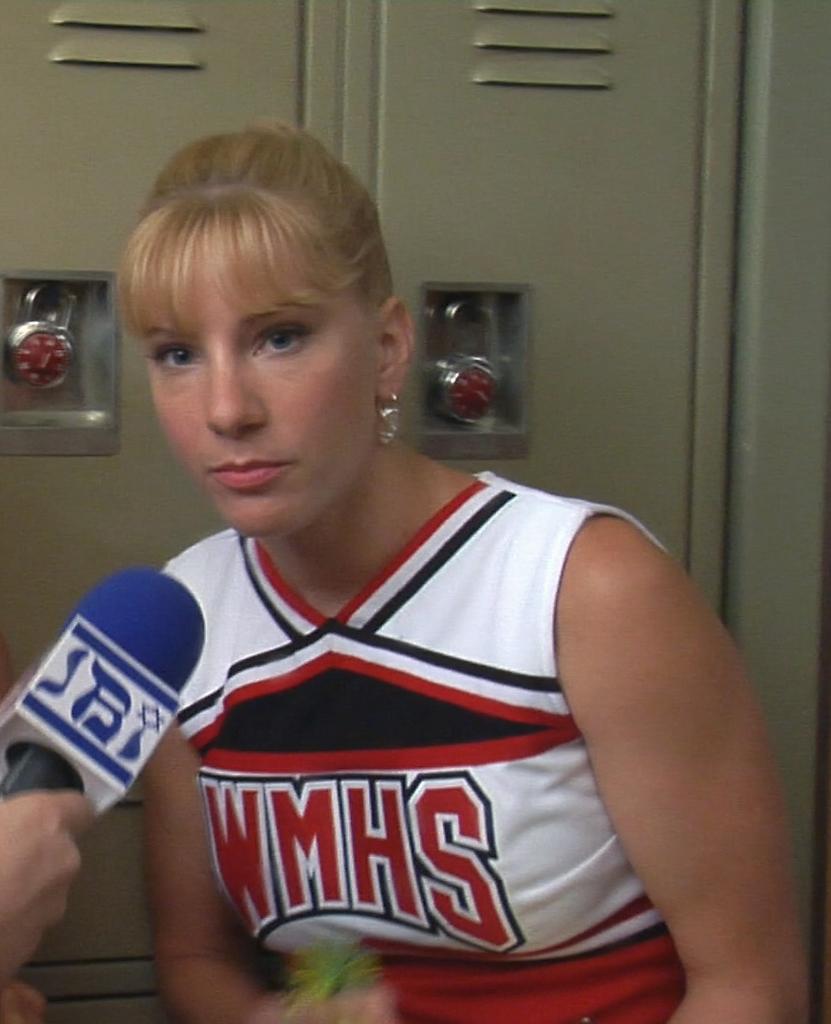Which school is she cheerleading for?
Make the answer very short. Wmhs. 